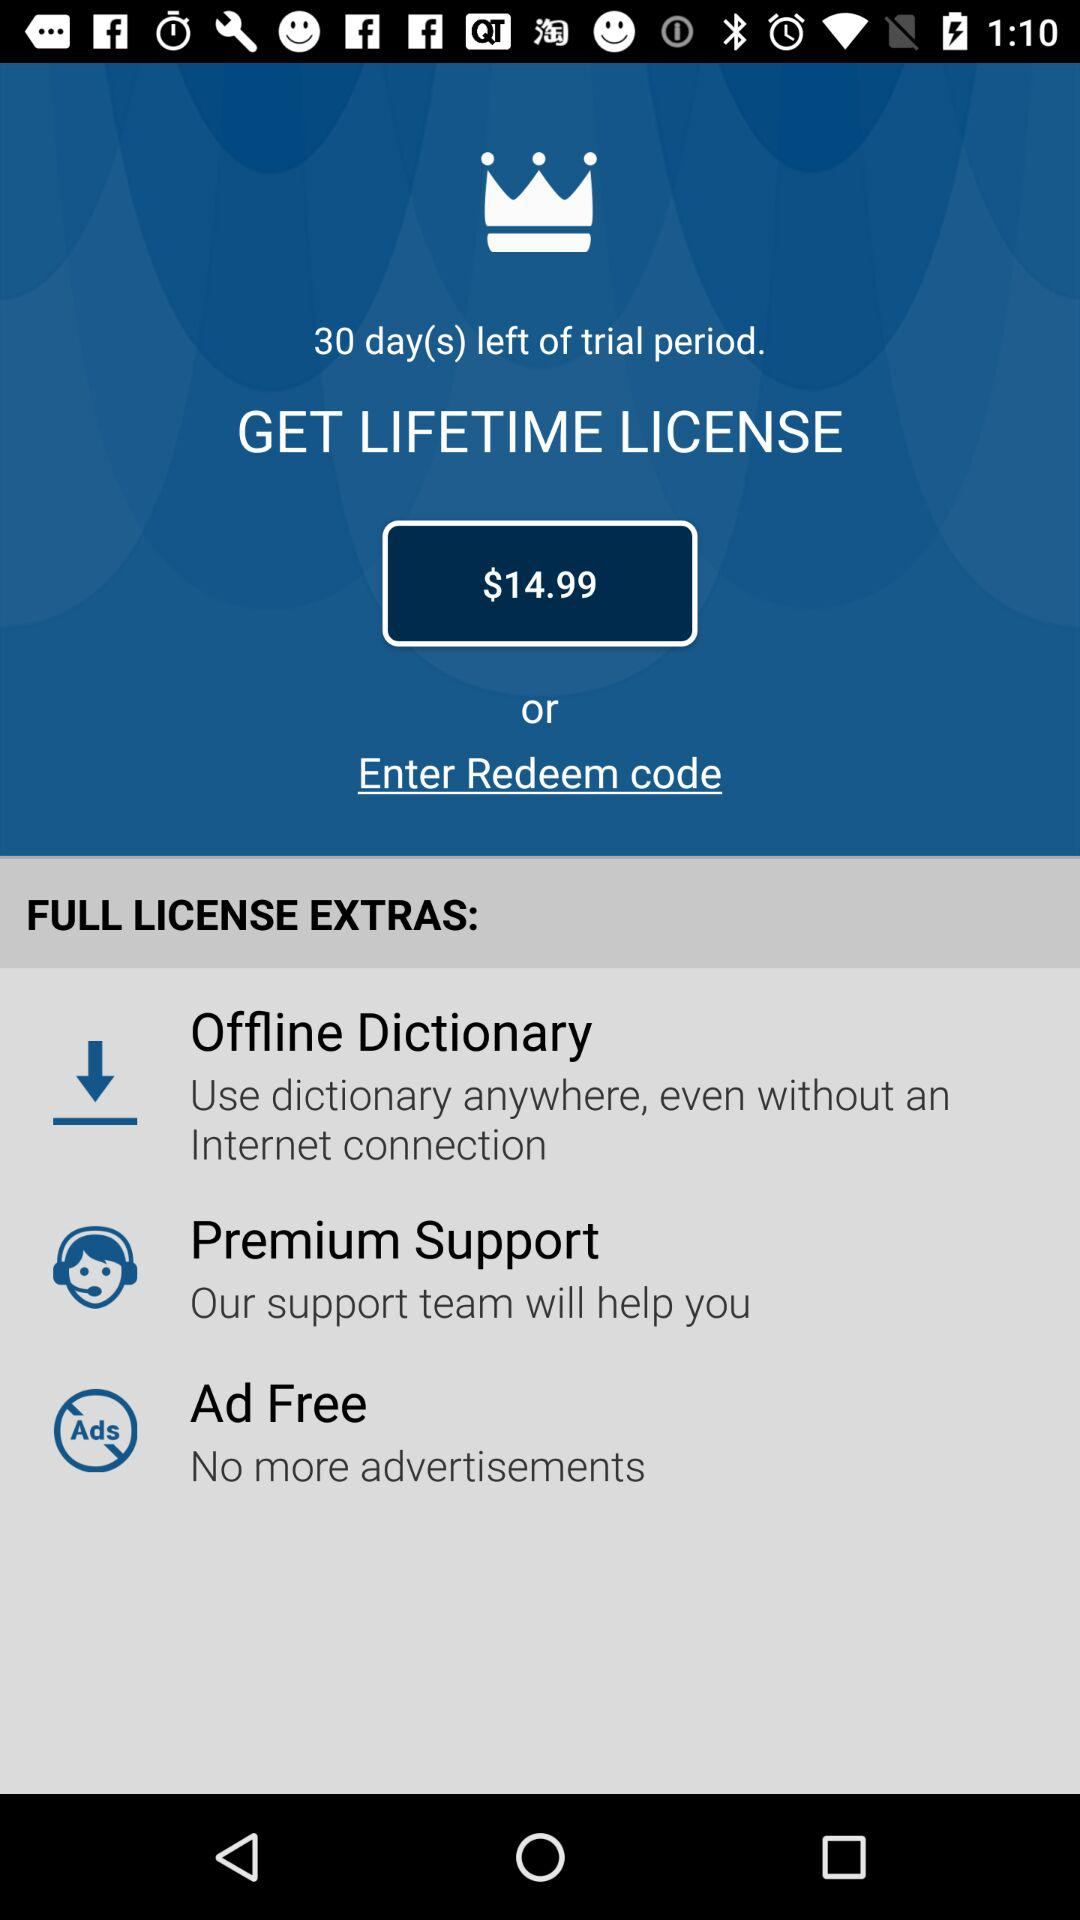How many days are left of the free trial period? There are 30 days left of the free trial period. 